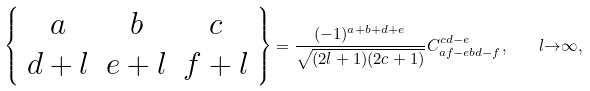<formula> <loc_0><loc_0><loc_500><loc_500>\left \{ \begin{array} { c c c } a & b & c \\ d + l & e + l & f + l \end{array} \right \} = \frac { ( - 1 ) ^ { a + b + d + e } } { \sqrt { ( 2 l + 1 ) ( 2 c + 1 ) } } C ^ { c d - e } _ { a f - e b d - f } , \quad l { \rightarrow } { \infty } ,</formula> 